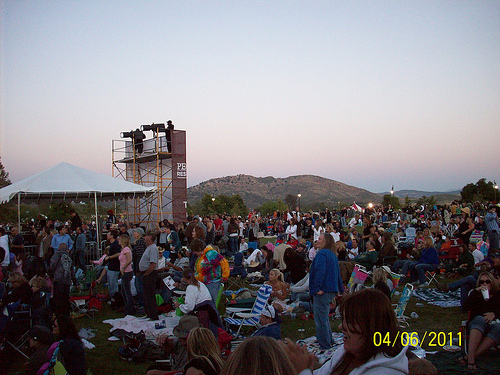<image>
Is there a light in front of the mountain? Yes. The light is positioned in front of the mountain, appearing closer to the camera viewpoint. 